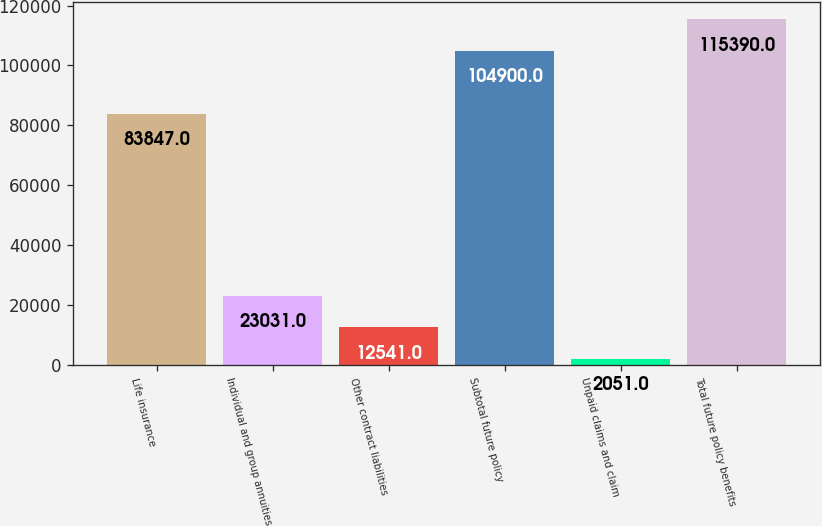Convert chart. <chart><loc_0><loc_0><loc_500><loc_500><bar_chart><fcel>Life insurance<fcel>Individual and group annuities<fcel>Other contract liabilities<fcel>Subtotal future policy<fcel>Unpaid claims and claim<fcel>Total future policy benefits<nl><fcel>83847<fcel>23031<fcel>12541<fcel>104900<fcel>2051<fcel>115390<nl></chart> 